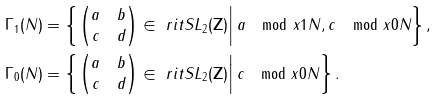Convert formula to latex. <formula><loc_0><loc_0><loc_500><loc_500>\Gamma _ { 1 } ( N ) & = \left \{ \left . \begin{pmatrix} a & b \\ c & d \end{pmatrix} \in \ r i t { S L } _ { 2 } ( \mathbf Z ) \right | a \mod x 1 N , c \mod x 0 N \right \} , \\ \Gamma _ { 0 } ( N ) & = \left \{ \left . \begin{pmatrix} a & b \\ c & d \end{pmatrix} \in \ r i t { S L } _ { 2 } ( \mathbf Z ) \right | c \mod x 0 N \right \} .</formula> 